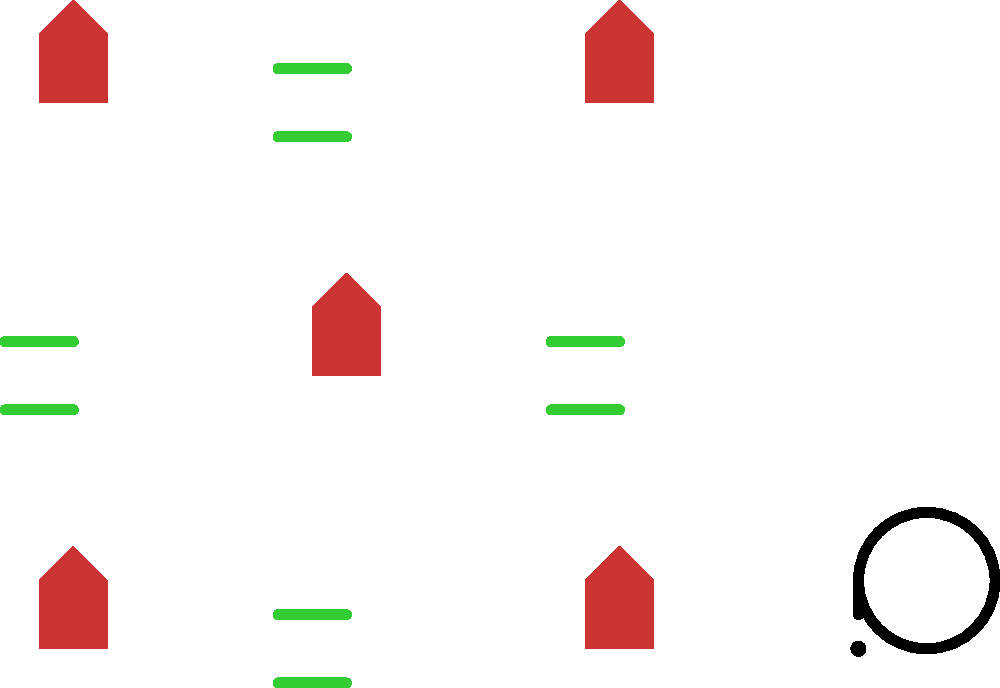Analyze the pattern of symbols in the 3x3 grid. Which symbol should logically appear in place of the question mark to complete the sequence? To solve this spatial intelligence question, let's break down the pattern:

1. The grid contains three distinct symbols:
   a) A red Venus symbol (♀), representing femininity and women's rights
   b) A blue raised fist, symbolizing solidarity and resistance
   c) Two green parallel lines, representing equality

2. Observe the distribution of symbols:
   a) The Venus symbol appears in alternating positions (0,0), (0,2), (1,1), (2,0), (2,2)
   b) The raised fist appears on the diagonal from top-left to bottom-right (0,0), (1,1), (2,2)
   c) The equality symbol fills the remaining positions (0,1), (1,0), (1,2), (2,1)

3. Notice that the raised fist overrides the Venus symbol in the diagonal positions

4. The question mark is positioned outside the grid, suggesting we need to determine which symbol would logically continue the pattern if the grid were extended

5. If we extend the pattern:
   a) The next position would be (3,0), which is an even sum of coordinates (3+0=3)
   b) Even sum positions are filled with the Venus symbol

Therefore, the logical continuation of the pattern would place the Venus symbol (♀) in the position of the question mark.
Answer: Venus symbol (♀) 